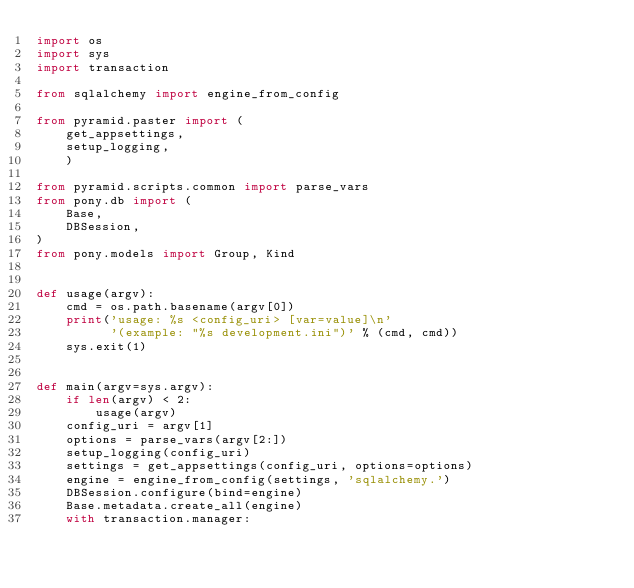<code> <loc_0><loc_0><loc_500><loc_500><_Python_>import os
import sys
import transaction

from sqlalchemy import engine_from_config

from pyramid.paster import (
    get_appsettings,
    setup_logging,
    )

from pyramid.scripts.common import parse_vars
from pony.db import (
    Base,
    DBSession,
)
from pony.models import Group, Kind


def usage(argv):
    cmd = os.path.basename(argv[0])
    print('usage: %s <config_uri> [var=value]\n'
          '(example: "%s development.ini")' % (cmd, cmd))
    sys.exit(1)


def main(argv=sys.argv):
    if len(argv) < 2:
        usage(argv)
    config_uri = argv[1]
    options = parse_vars(argv[2:])
    setup_logging(config_uri)
    settings = get_appsettings(config_uri, options=options)
    engine = engine_from_config(settings, 'sqlalchemy.')
    DBSession.configure(bind=engine)
    Base.metadata.create_all(engine)
    with transaction.manager:</code> 